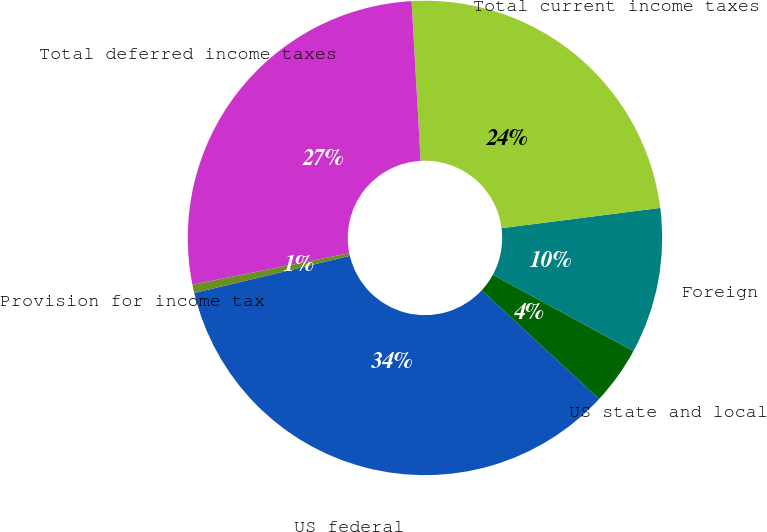<chart> <loc_0><loc_0><loc_500><loc_500><pie_chart><fcel>US federal<fcel>US state and local<fcel>Foreign<fcel>Total current income taxes<fcel>Total deferred income taxes<fcel>Provision for income tax<nl><fcel>34.4%<fcel>3.96%<fcel>9.93%<fcel>23.88%<fcel>27.26%<fcel>0.57%<nl></chart> 